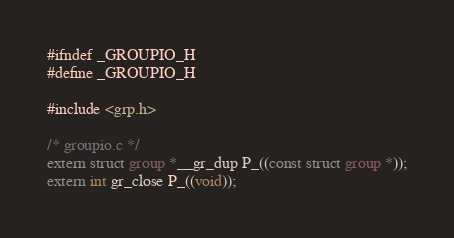Convert code to text. <code><loc_0><loc_0><loc_500><loc_500><_C_>#ifndef _GROUPIO_H
#define _GROUPIO_H

#include <grp.h>

/* groupio.c */
extern struct group *__gr_dup P_((const struct group *));
extern int gr_close P_((void));</code> 